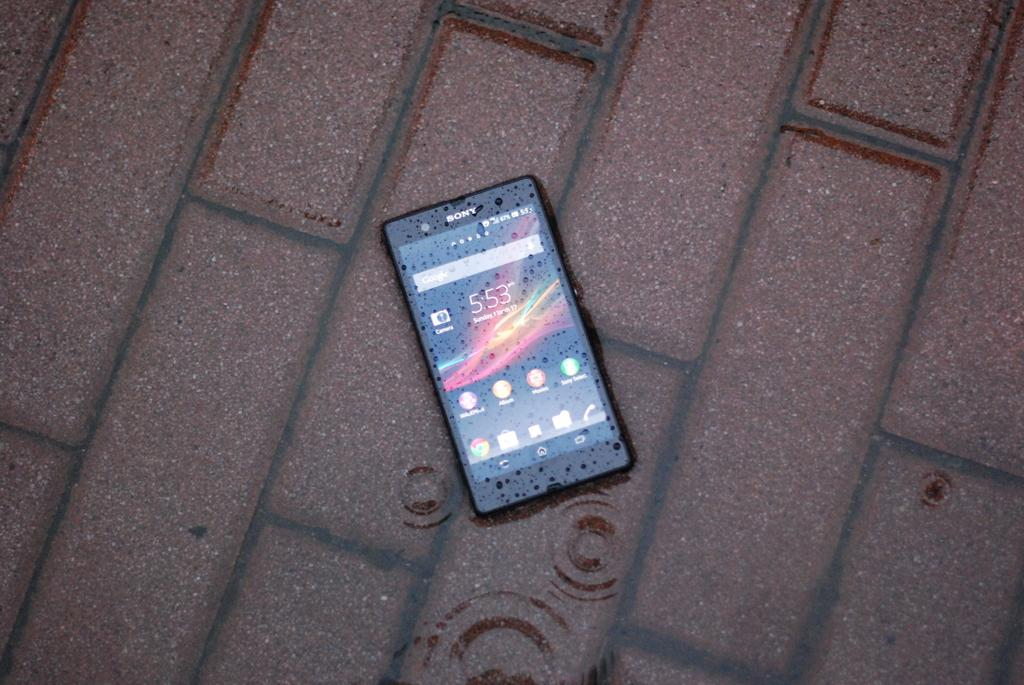<image>
Relay a brief, clear account of the picture shown. a phone that has the time of 5:53 on it 